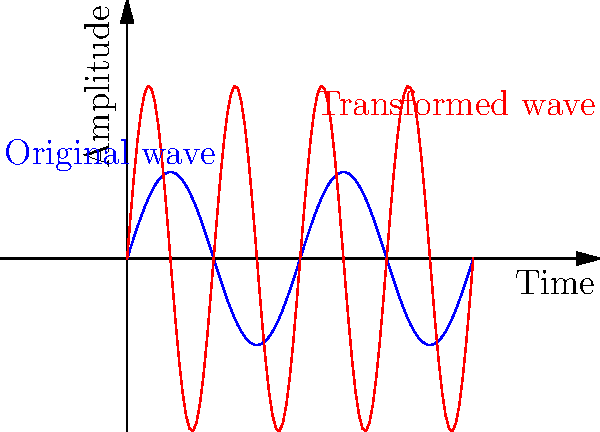In the graph above, the blue curve represents an original sound wave from a viola, and the red curve shows a transformed version of the same wave. If the transformation applied is a dilation with scale factor $k$ in both the $x$ and $y$ directions, what is the value of $k$ that transforms the blue wave into the red wave? How does this transformation affect the pitch and volume of the sound? To determine the scale factor $k$ and its effects on pitch and volume, let's analyze the transformation step-by-step:

1) First, observe the change in frequency:
   - The blue wave completes one cycle in the given time frame.
   - The red wave completes two cycles in the same time frame.
   - This indicates that the frequency has doubled, meaning the time scale (x-axis) has been compressed by a factor of 1/2.

2) Now, look at the change in amplitude:
   - The maximum amplitude of the blue wave is 0.5.
   - The maximum amplitude of the red wave is 1.
   - This shows that the amplitude has doubled.

3) The dilation scale factor $k$ is applied to both x and y directions:
   - For the x-direction (time): $k_x = 1/2$
   - For the y-direction (amplitude): $k_y = 2$
   - Since these are equal in magnitude and opposite in direction, we can conclude that $k = 2$.

4) Effects on pitch and volume:
   - Pitch is related to frequency. Since the frequency doubled (time scale halved), the pitch increases by one octave.
   - Volume is related to amplitude. Since the amplitude doubled, the volume increases.

Therefore, the dilation with scale factor $k = 2$ results in:
- A higher pitch (one octave higher)
- An increase in volume
Answer: $k = 2$; pitch increases by one octave, volume increases 